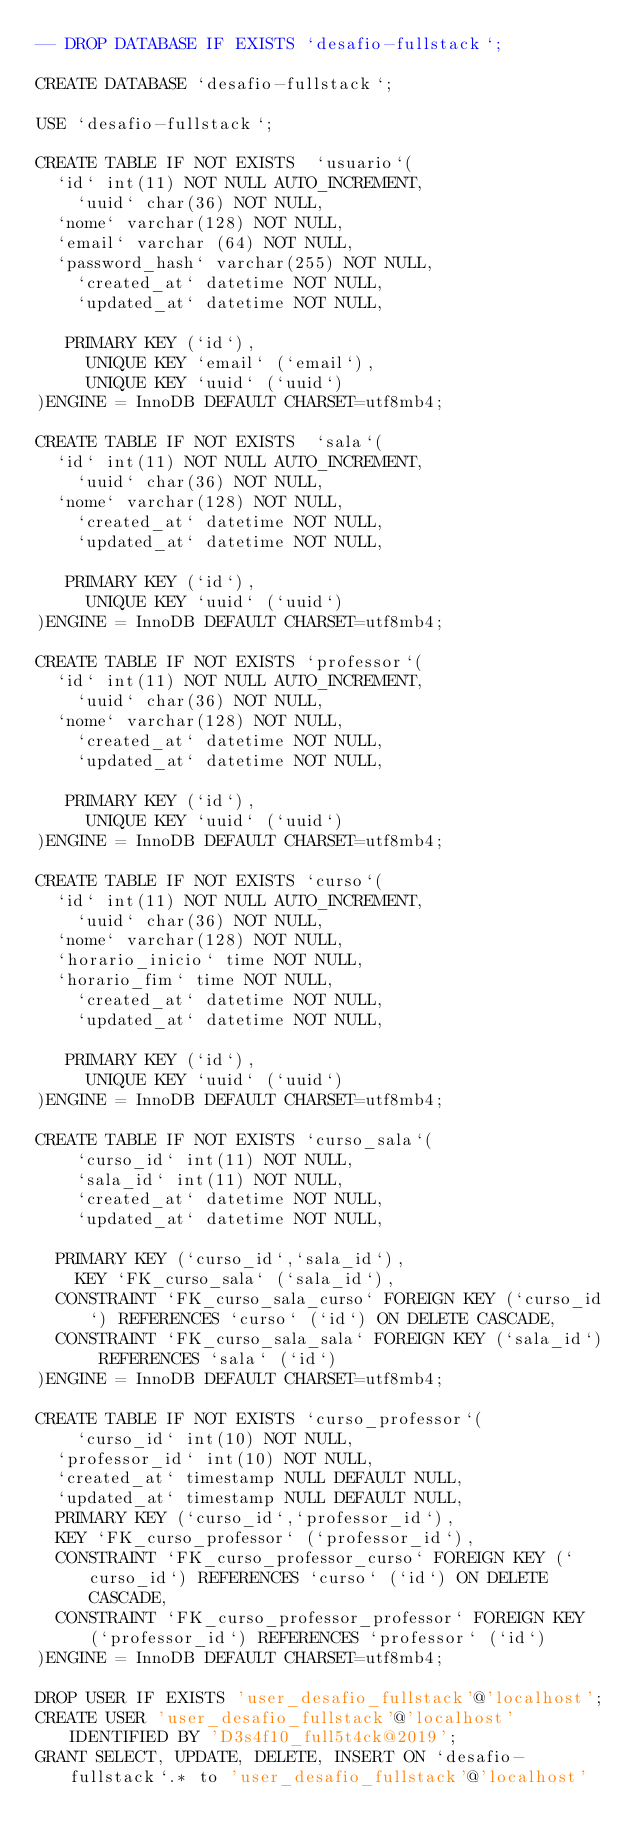Convert code to text. <code><loc_0><loc_0><loc_500><loc_500><_SQL_>-- DROP DATABASE IF EXISTS `desafio-fullstack`;

CREATE DATABASE `desafio-fullstack`;

USE `desafio-fullstack`;

CREATE TABLE IF NOT EXISTS  `usuario`(	
	`id` int(11) NOT NULL AUTO_INCREMENT,    
    `uuid` char(36) NOT NULL,
	`nome` varchar(128) NOT NULL,    
	`email` varchar (64) NOT NULL,    
	`password_hash` varchar(255) NOT NULL,
    `created_at` datetime NOT NULL,	
    `updated_at` datetime NOT NULL,
   
	 PRIMARY KEY (`id`),     
     UNIQUE KEY `email` (`email`),
     UNIQUE KEY `uuid` (`uuid`)
)ENGINE = InnoDB DEFAULT CHARSET=utf8mb4;

CREATE TABLE IF NOT EXISTS  `sala`(	
	`id` int(11) NOT NULL AUTO_INCREMENT,    
    `uuid` char(36) NOT NULL,
	`nome` varchar(128) NOT NULL,    	
    `created_at` datetime NOT NULL,	
    `updated_at` datetime NOT NULL,
   
	 PRIMARY KEY (`id`),
     UNIQUE KEY `uuid` (`uuid`)
)ENGINE = InnoDB DEFAULT CHARSET=utf8mb4;

CREATE TABLE IF NOT EXISTS `professor`(	
	`id` int(11) NOT NULL AUTO_INCREMENT,    
    `uuid` char(36) NOT NULL,
	`nome` varchar(128) NOT NULL,    	
    `created_at` datetime NOT NULL,	
    `updated_at` datetime NOT NULL,
   
	 PRIMARY KEY (`id`),
     UNIQUE KEY `uuid` (`uuid`)
)ENGINE = InnoDB DEFAULT CHARSET=utf8mb4;

CREATE TABLE IF NOT EXISTS `curso`(	
	`id` int(11) NOT NULL AUTO_INCREMENT,    
    `uuid` char(36) NOT NULL,
	`nome` varchar(128) NOT NULL,    	    
	`horario_inicio` time NOT NULL,
	`horario_fim` time NOT NULL,
    `created_at` datetime NOT NULL,	
    `updated_at` datetime NOT NULL,
   
	 PRIMARY KEY (`id`),
     UNIQUE KEY `uuid` (`uuid`)
)ENGINE = InnoDB DEFAULT CHARSET=utf8mb4;

CREATE TABLE IF NOT EXISTS `curso_sala`(	
    `curso_id` int(11) NOT NULL,
    `sala_id` int(11) NOT NULL, 	
    `created_at` datetime NOT NULL,	
    `updated_at` datetime NOT NULL,
   
	PRIMARY KEY (`curso_id`,`sala_id`),
    KEY `FK_curso_sala` (`sala_id`),
	CONSTRAINT `FK_curso_sala_curso` FOREIGN KEY (`curso_id`) REFERENCES `curso` (`id`) ON DELETE CASCADE,
	CONSTRAINT `FK_curso_sala_sala` FOREIGN KEY (`sala_id`) REFERENCES `sala` (`id`) 
)ENGINE = InnoDB DEFAULT CHARSET=utf8mb4;

CREATE TABLE IF NOT EXISTS `curso_professor`(	
    `curso_id` int(10) NOT NULL,
	`professor_id` int(10) NOT NULL,
	`created_at` timestamp NULL DEFAULT NULL,
	`updated_at` timestamp NULL DEFAULT NULL,
	PRIMARY KEY (`curso_id`,`professor_id`),
	KEY `FK_curso_professor` (`professor_id`),
	CONSTRAINT `FK_curso_professor_curso` FOREIGN KEY (`curso_id`) REFERENCES `curso` (`id`) ON DELETE CASCADE,
	CONSTRAINT `FK_curso_professor_professor` FOREIGN KEY (`professor_id`) REFERENCES `professor` (`id`) 
)ENGINE = InnoDB DEFAULT CHARSET=utf8mb4;

DROP USER IF EXISTS 'user_desafio_fullstack'@'localhost';
CREATE USER 'user_desafio_fullstack'@'localhost' IDENTIFIED BY 'D3s4f10_full5t4ck@2019';
GRANT SELECT, UPDATE, DELETE, INSERT ON `desafio-fullstack`.* to 'user_desafio_fullstack'@'localhost'
</code> 